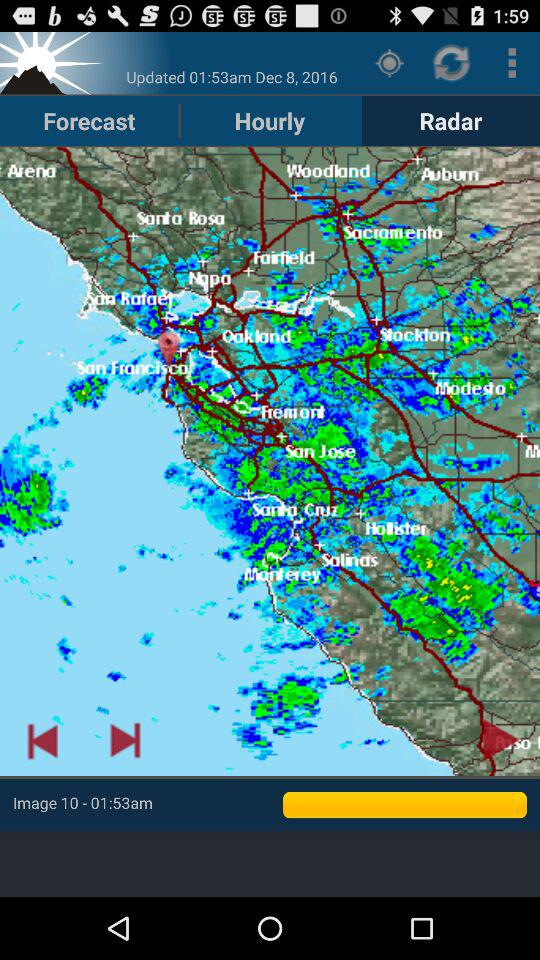What is the updated date and time shown? The updated date and time shown is December 8, 2016 at 1:53 am. 